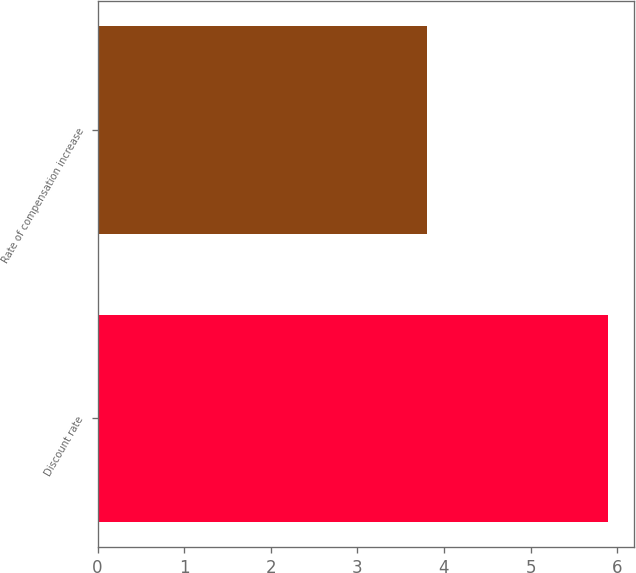Convert chart. <chart><loc_0><loc_0><loc_500><loc_500><bar_chart><fcel>Discount rate<fcel>Rate of compensation increase<nl><fcel>5.9<fcel>3.8<nl></chart> 